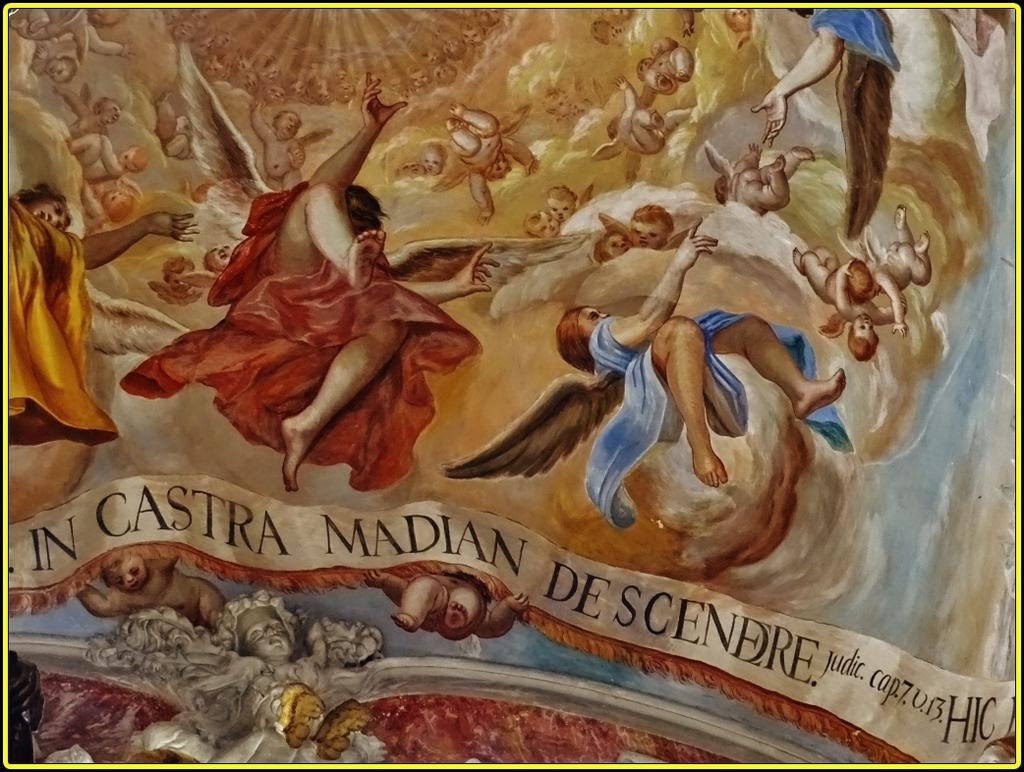<image>
Relay a brief, clear account of the picture shown. In Castra is written under the image if people falling. 